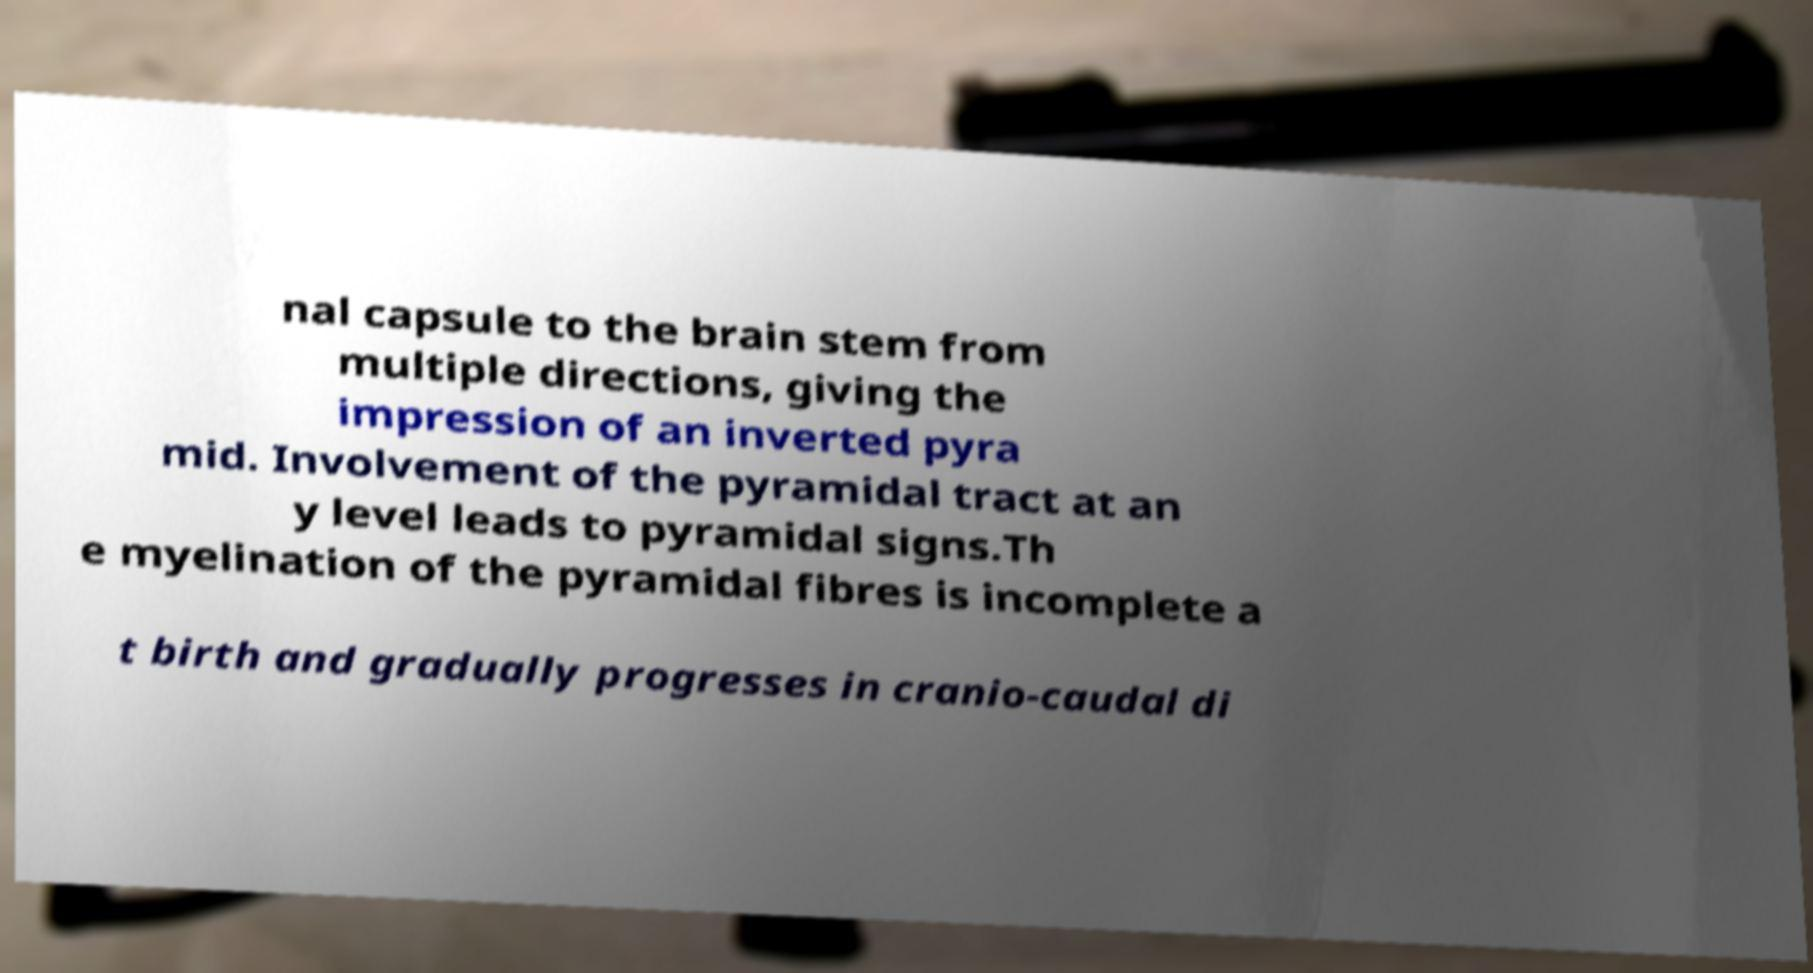Please identify and transcribe the text found in this image. nal capsule to the brain stem from multiple directions, giving the impression of an inverted pyra mid. Involvement of the pyramidal tract at an y level leads to pyramidal signs.Th e myelination of the pyramidal fibres is incomplete a t birth and gradually progresses in cranio-caudal di 